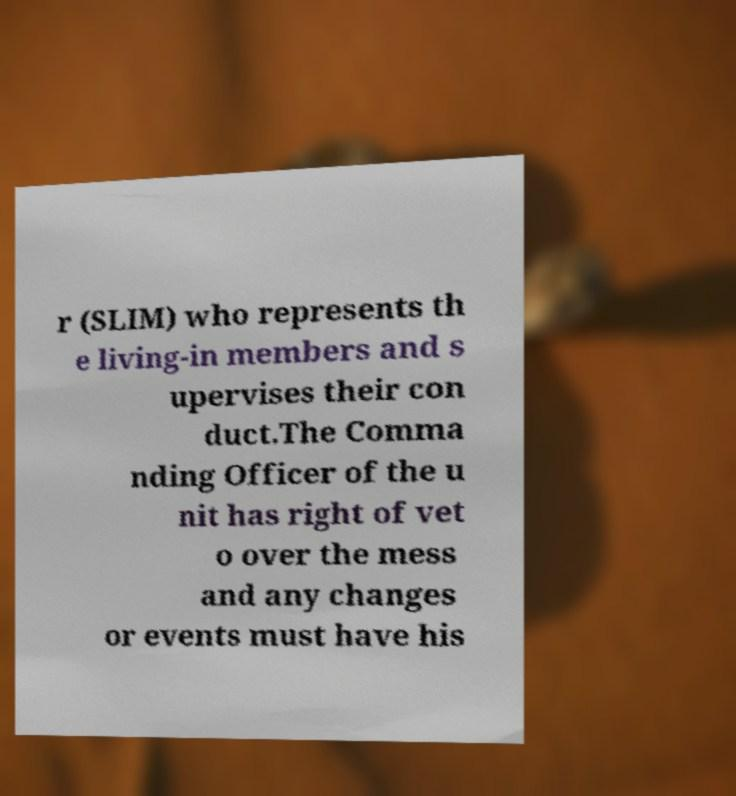Can you accurately transcribe the text from the provided image for me? r (SLIM) who represents th e living-in members and s upervises their con duct.The Comma nding Officer of the u nit has right of vet o over the mess and any changes or events must have his 